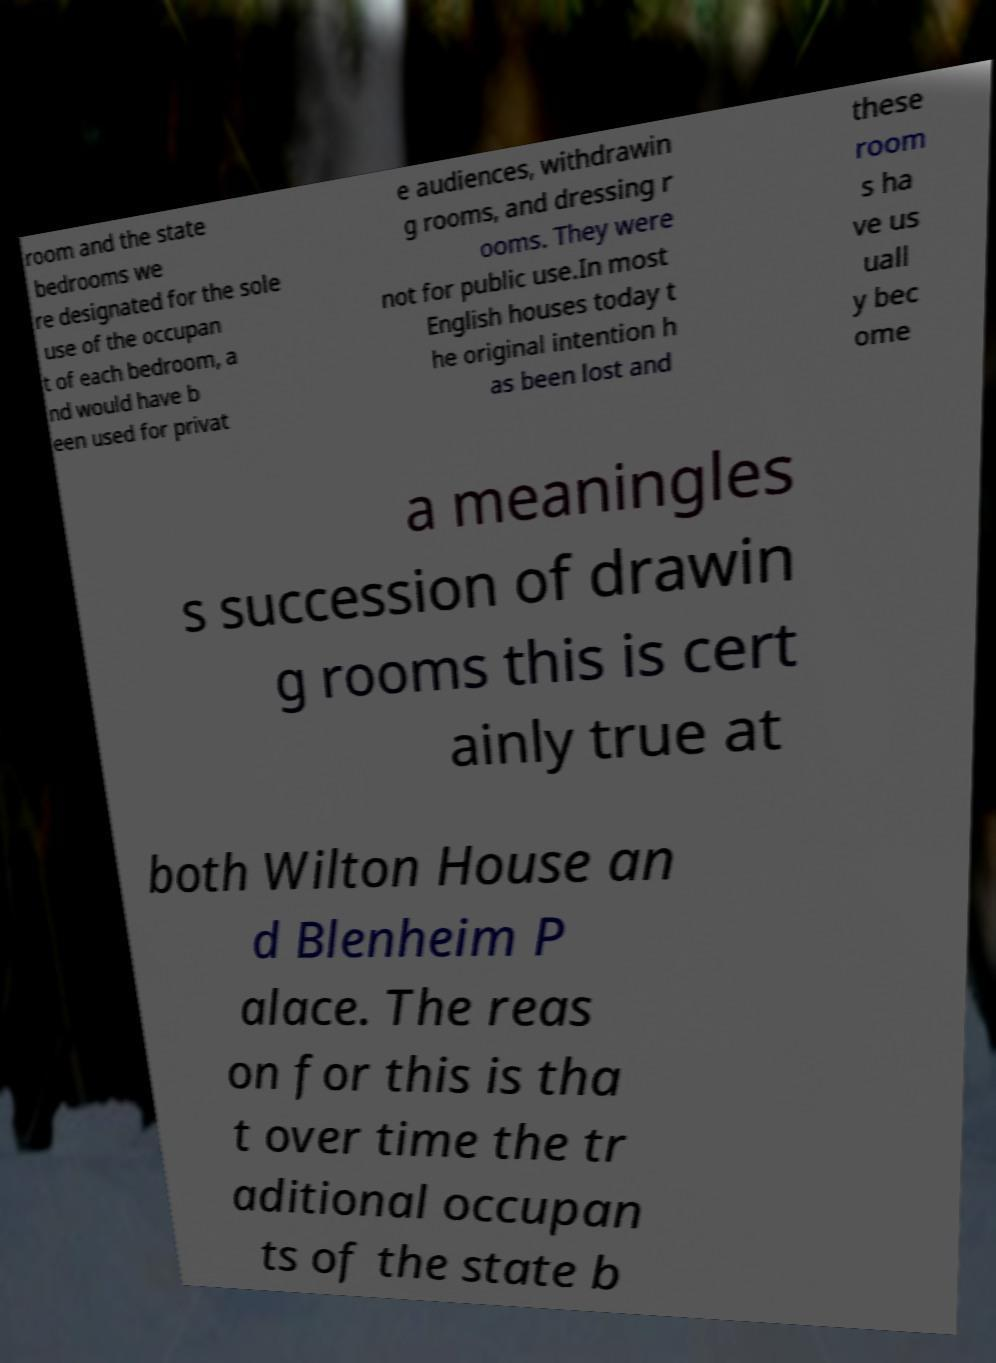Could you extract and type out the text from this image? room and the state bedrooms we re designated for the sole use of the occupan t of each bedroom, a nd would have b een used for privat e audiences, withdrawin g rooms, and dressing r ooms. They were not for public use.In most English houses today t he original intention h as been lost and these room s ha ve us uall y bec ome a meaningles s succession of drawin g rooms this is cert ainly true at both Wilton House an d Blenheim P alace. The reas on for this is tha t over time the tr aditional occupan ts of the state b 